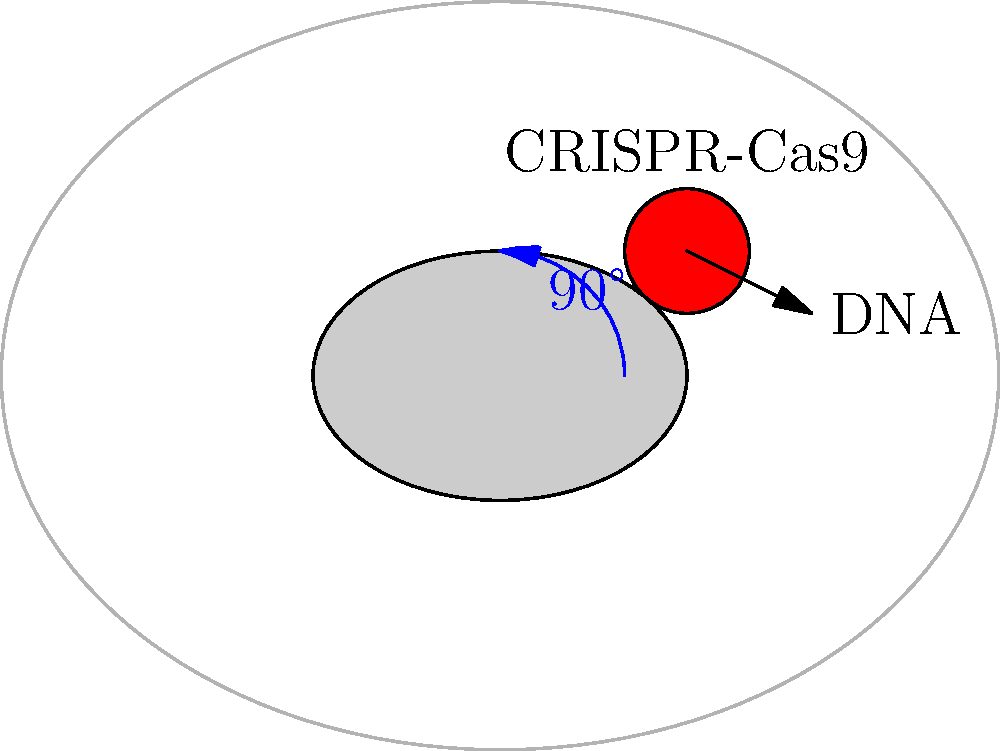In the context of CRISPR-Cas9 gene editing, consider the cell diagram above. If the entire diagram is rotated 90° clockwise, which of the following statements is true regarding the ethical implications of the gene editing process?

A) The rotation changes the target DNA sequence, potentially altering off-target effects.
B) The new perspective emphasizes the need for careful consideration of unintended consequences.
C) The clockwise rotation symbolizes the accelerated pace of gene editing advancements.
D) The altered view has no bearing on the ethical considerations of CRISPR-Cas9 use. To answer this question, we need to consider the following steps:

1. Understand that the rotation of the diagram is merely a change in perspective and does not alter the actual gene editing process or its implications.

2. Recognize that as bioethics researchers, we are concerned with the ethical implications of CRISPR-Cas9 gene editing, regardless of how the process is visually represented.

3. Analyze each option:

   A) Incorrect. Rotating the diagram does not change the actual DNA sequence or off-target effects.
   
   B) Correct. While the rotation itself doesn't change the process, a new perspective can metaphorically represent the need to view gene editing from multiple angles, emphasizing careful consideration of all potential consequences.
   
   C) Incorrect. The direction of rotation has no inherent meaning related to the pace of advancements.
   
   D) Incorrect. While the rotation doesn't change the process, it can serve as a reminder to consider multiple perspectives in ethical discussions.

4. Conclude that option B is the most appropriate answer, as it aligns with the bioethical perspective of thoroughly examining all aspects and potential consequences of gene editing.
Answer: B 